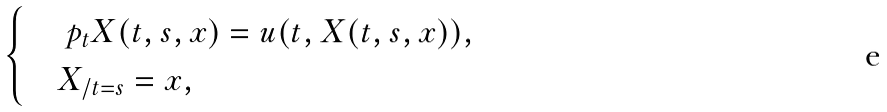<formula> <loc_0><loc_0><loc_500><loc_500>\begin{cases} & \ p _ { t } X ( t , s , x ) = u ( t , X ( t , s , x ) ) , \\ & X _ { / t = s } = x , \end{cases}</formula> 